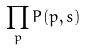Convert formula to latex. <formula><loc_0><loc_0><loc_500><loc_500>\prod _ { p } P ( p , s )</formula> 